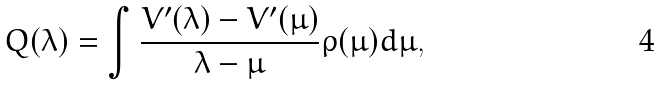Convert formula to latex. <formula><loc_0><loc_0><loc_500><loc_500>Q ( \lambda ) = \int \frac { V ^ { \prime } ( \lambda ) - V ^ { \prime } ( \mu ) } { \lambda - \mu } \rho ( \mu ) d \mu ,</formula> 